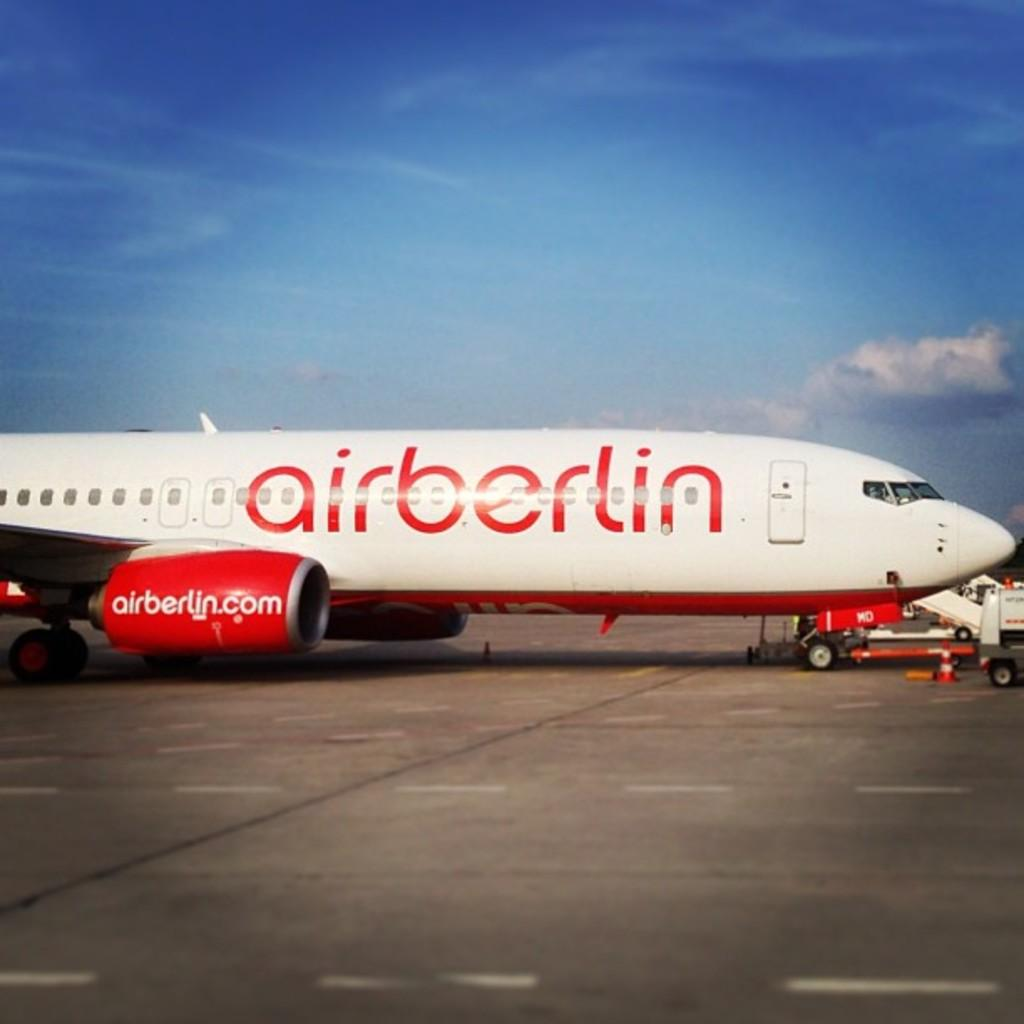<image>
Offer a succinct explanation of the picture presented. Airberlin flight Airplane that shows the front of the plane. 